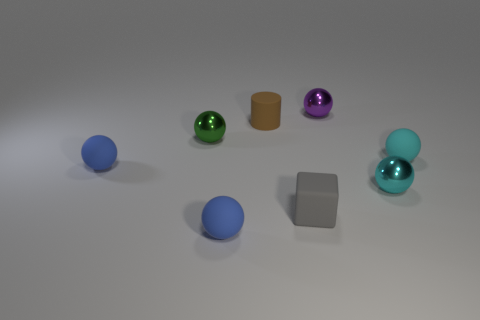Is the number of small purple metallic things that are in front of the tiny purple metal thing the same as the number of small objects on the left side of the rubber cube?
Your response must be concise. No. There is a cyan thing on the right side of the small cyan shiny thing; does it have the same shape as the tiny blue thing in front of the cyan metallic object?
Keep it short and to the point. Yes. Are there any other things that are the same shape as the gray rubber object?
Offer a very short reply. No. What shape is the purple object that is made of the same material as the green thing?
Your answer should be very brief. Sphere. Are there the same number of tiny cyan rubber balls that are left of the small gray matte object and small cyan spheres?
Make the answer very short. No. Are the tiny green ball in front of the brown rubber cylinder and the sphere that is behind the brown matte object made of the same material?
Offer a very short reply. Yes. There is a tiny blue matte object in front of the metallic sphere right of the purple object; what is its shape?
Your response must be concise. Sphere. What is the color of the block that is made of the same material as the small brown thing?
Your response must be concise. Gray. Does the block have the same color as the matte cylinder?
Provide a short and direct response. No. There is a cyan matte thing that is the same size as the brown matte thing; what is its shape?
Make the answer very short. Sphere. 